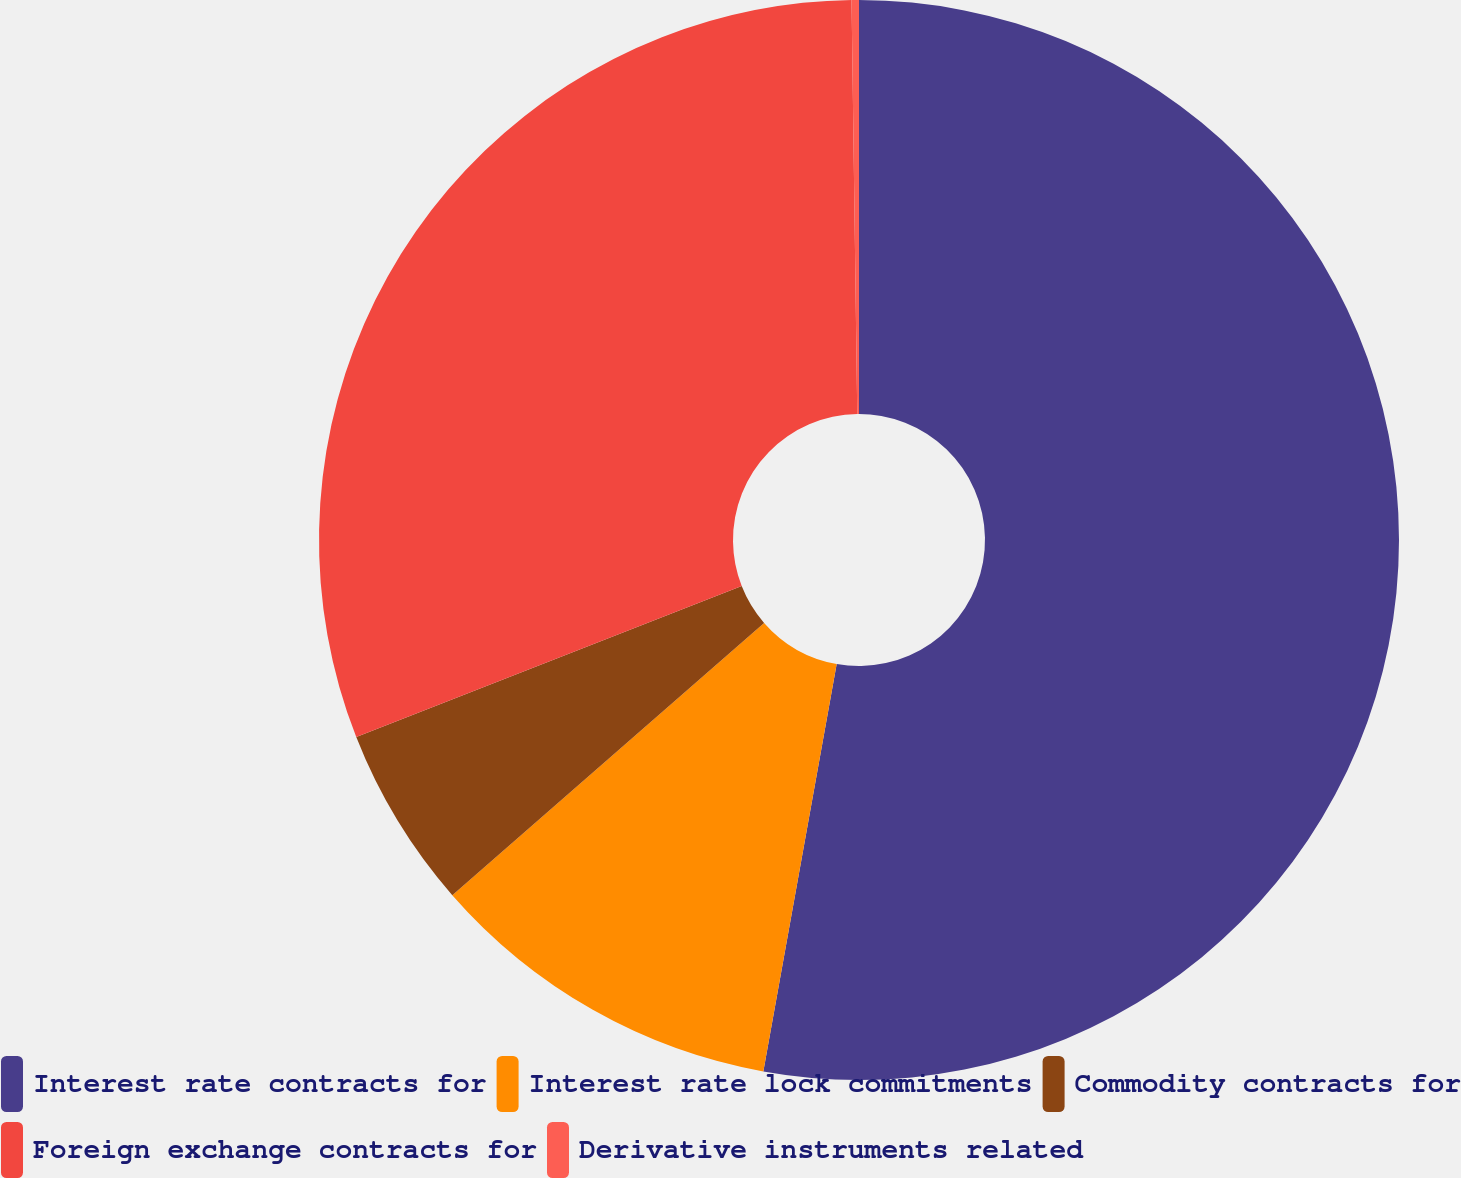Convert chart to OTSL. <chart><loc_0><loc_0><loc_500><loc_500><pie_chart><fcel>Interest rate contracts for<fcel>Interest rate lock commitments<fcel>Commodity contracts for<fcel>Foreign exchange contracts for<fcel>Derivative instruments related<nl><fcel>52.84%<fcel>10.74%<fcel>5.48%<fcel>30.73%<fcel>0.22%<nl></chart> 